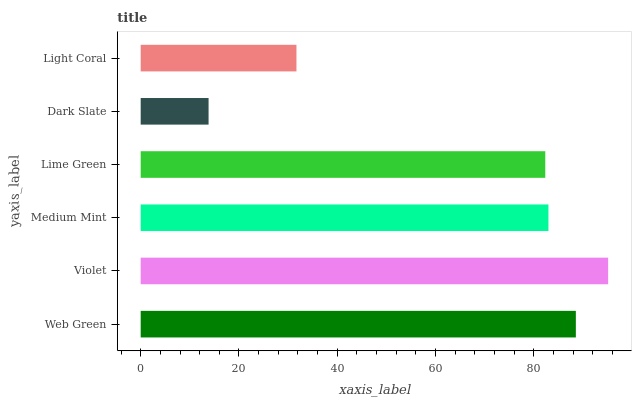Is Dark Slate the minimum?
Answer yes or no. Yes. Is Violet the maximum?
Answer yes or no. Yes. Is Medium Mint the minimum?
Answer yes or no. No. Is Medium Mint the maximum?
Answer yes or no. No. Is Violet greater than Medium Mint?
Answer yes or no. Yes. Is Medium Mint less than Violet?
Answer yes or no. Yes. Is Medium Mint greater than Violet?
Answer yes or no. No. Is Violet less than Medium Mint?
Answer yes or no. No. Is Medium Mint the high median?
Answer yes or no. Yes. Is Lime Green the low median?
Answer yes or no. Yes. Is Lime Green the high median?
Answer yes or no. No. Is Violet the low median?
Answer yes or no. No. 